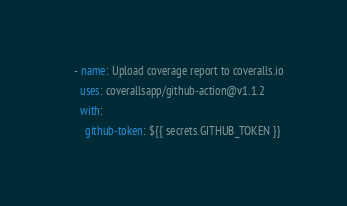Convert code to text. <code><loc_0><loc_0><loc_500><loc_500><_YAML_>
    - name: Upload coverage report to coveralls.io
      uses: coverallsapp/github-action@v1.1.2
      with:
        github-token: ${{ secrets.GITHUB_TOKEN }}
</code> 